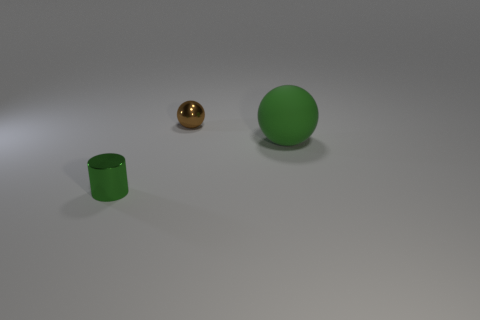Add 3 large green objects. How many objects exist? 6 Subtract all balls. How many objects are left? 1 Subtract all shiny things. Subtract all big cyan matte cylinders. How many objects are left? 1 Add 2 metallic objects. How many metallic objects are left? 4 Add 3 brown metal spheres. How many brown metal spheres exist? 4 Subtract 1 green cylinders. How many objects are left? 2 